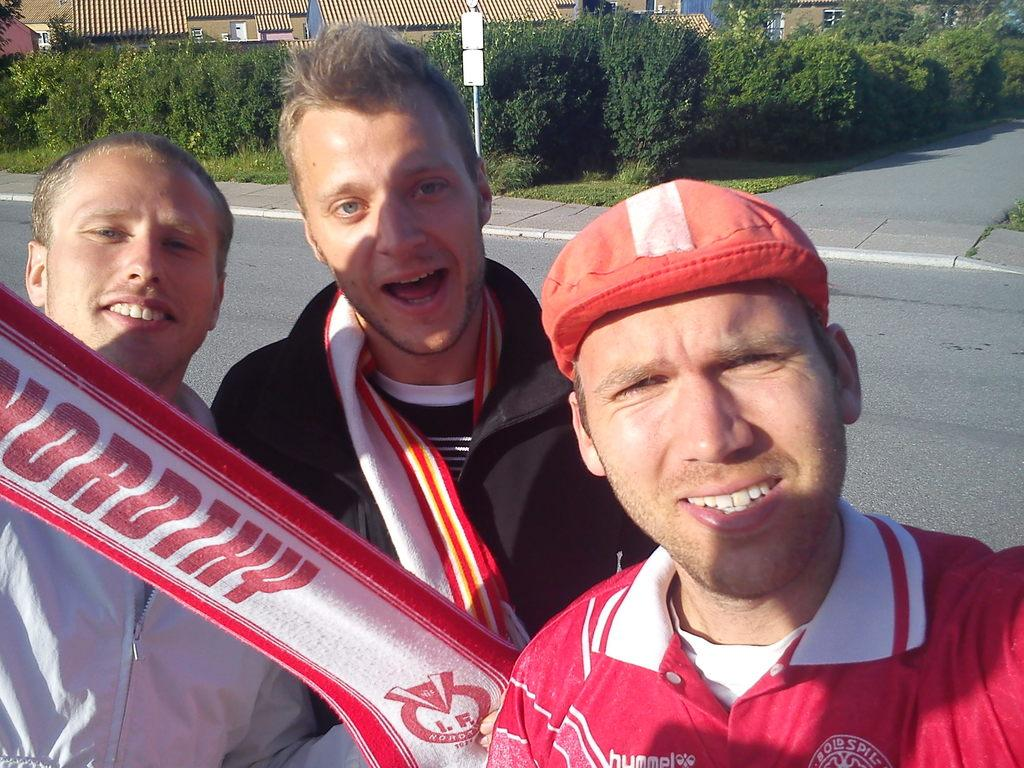What are the people in the image doing? The people in the image are taking pictures. What can be seen in the background of the image? There are trees and houses visible in the background of the image. What type of quiver can be seen on the road in the image? There is no quiver present in the image; it features people taking pictures on the road. 